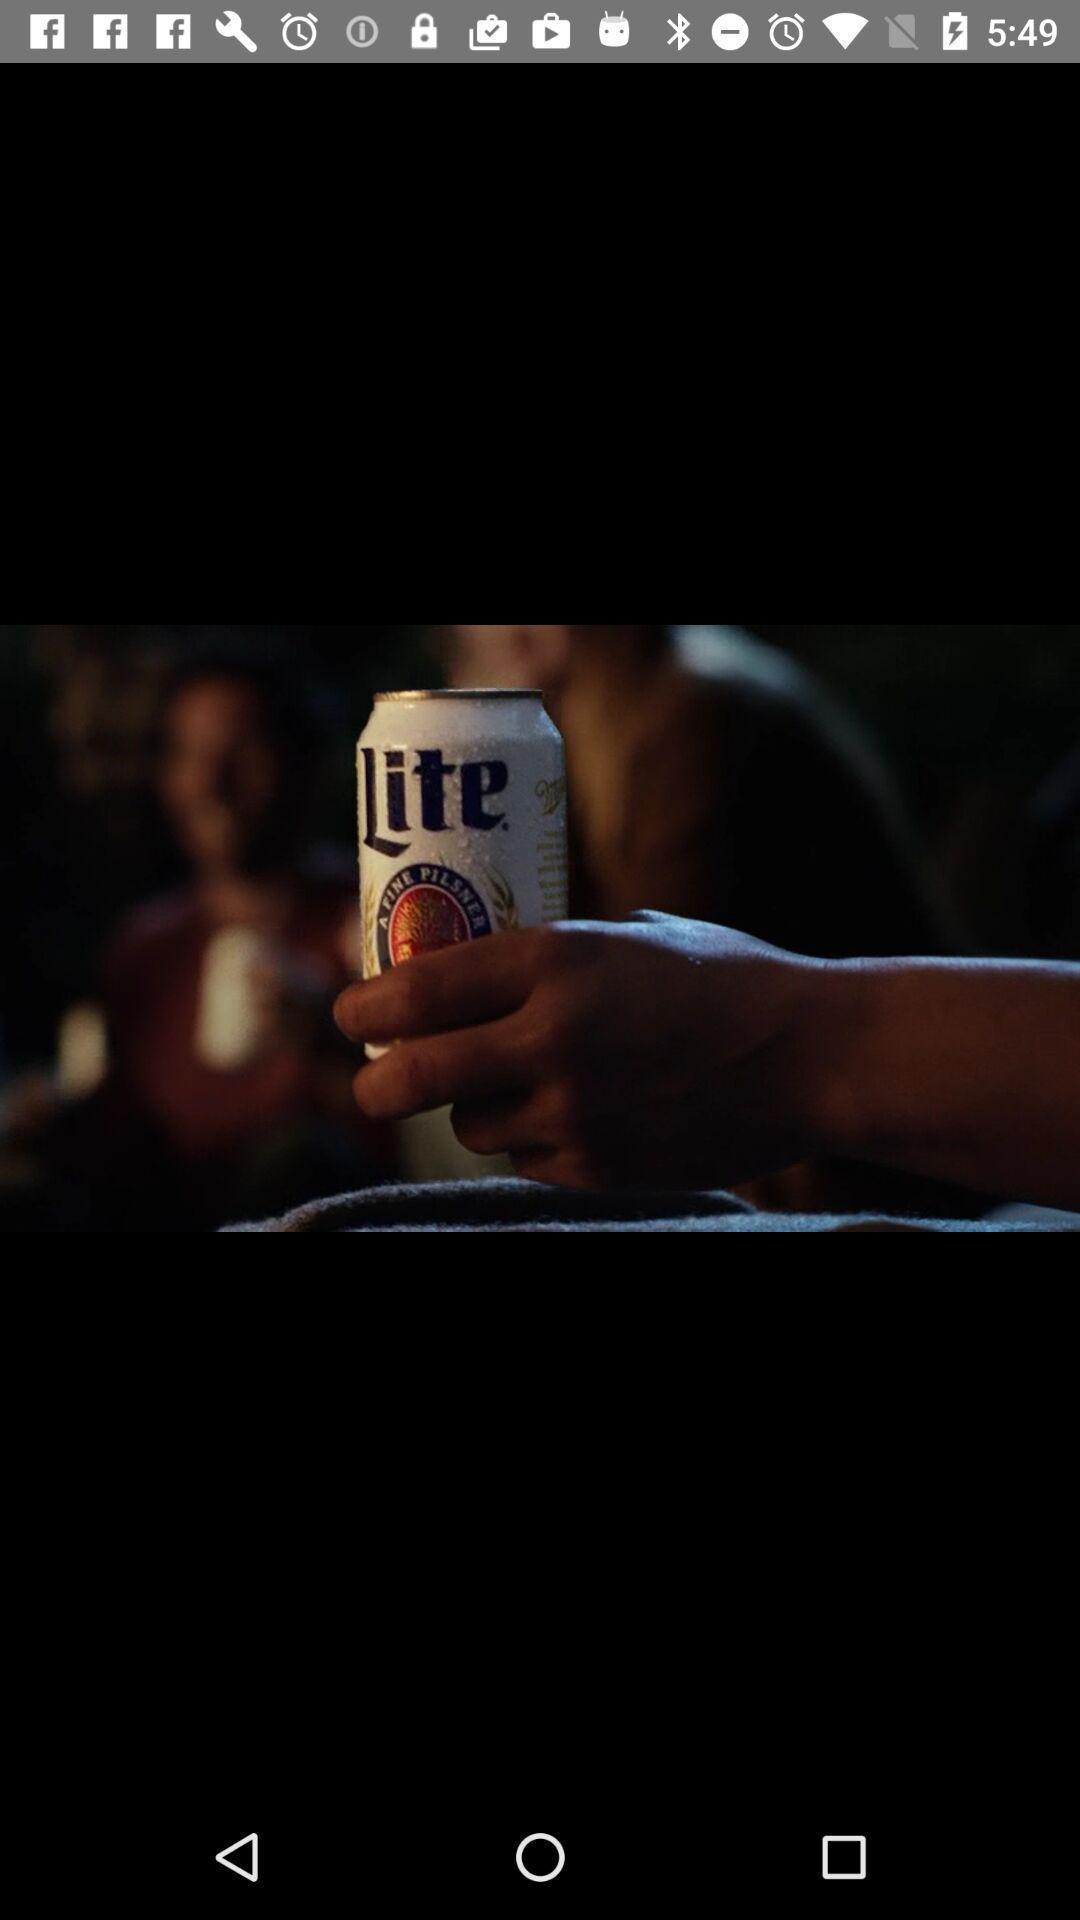Provide a detailed account of this screenshot. Page displaying the image on the screen. 